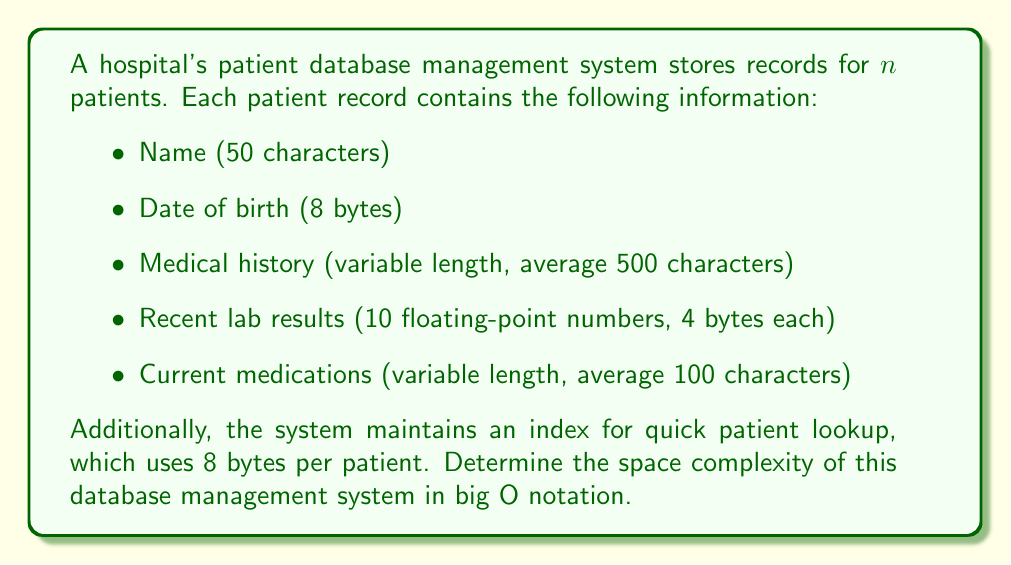What is the answer to this math problem? To determine the space complexity, we need to calculate the total space required for all patient records and the index:

1. Fixed-size components per patient:
   - Name: 50 characters * 1 byte/character = 50 bytes
   - Date of birth: 8 bytes
   - Lab results: 10 * 4 bytes = 40 bytes
   Total fixed size: 98 bytes

2. Variable-size components per patient (average):
   - Medical history: 500 characters * 1 byte/character = 500 bytes
   - Current medications: 100 characters * 1 byte/character = 100 bytes
   Total variable size: 600 bytes

3. Index entry per patient: 8 bytes

4. Total space per patient:
   $98 + 600 + 8 = 706$ bytes

5. For $n$ patients, the total space required is:
   $706n$ bytes

6. In big O notation, we ignore constant factors and focus on the growth rate with respect to $n$. The space requirement grows linearly with the number of patients.

Therefore, the space complexity of the patient database management system is $O(n)$.
Answer: $O(n)$ 